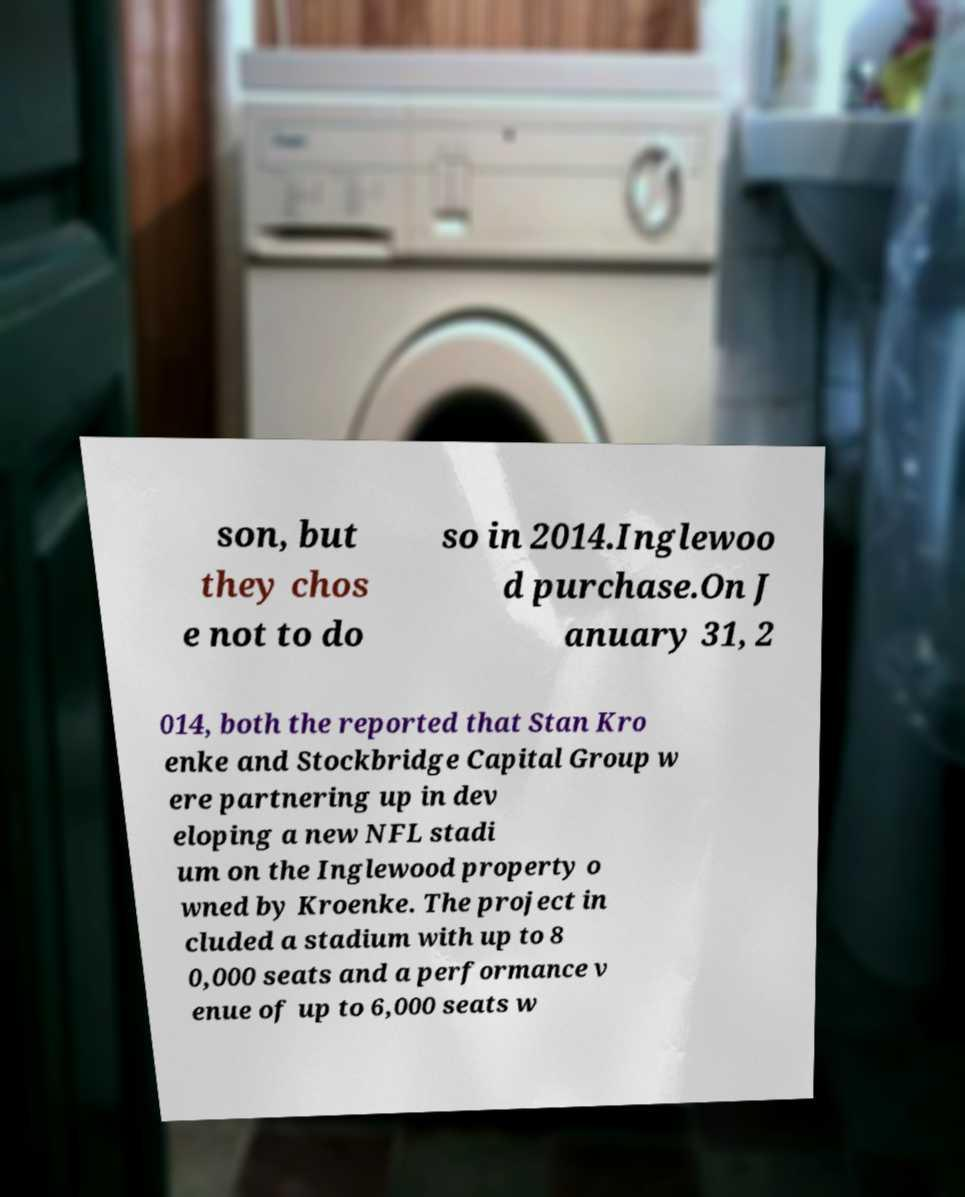Could you extract and type out the text from this image? son, but they chos e not to do so in 2014.Inglewoo d purchase.On J anuary 31, 2 014, both the reported that Stan Kro enke and Stockbridge Capital Group w ere partnering up in dev eloping a new NFL stadi um on the Inglewood property o wned by Kroenke. The project in cluded a stadium with up to 8 0,000 seats and a performance v enue of up to 6,000 seats w 